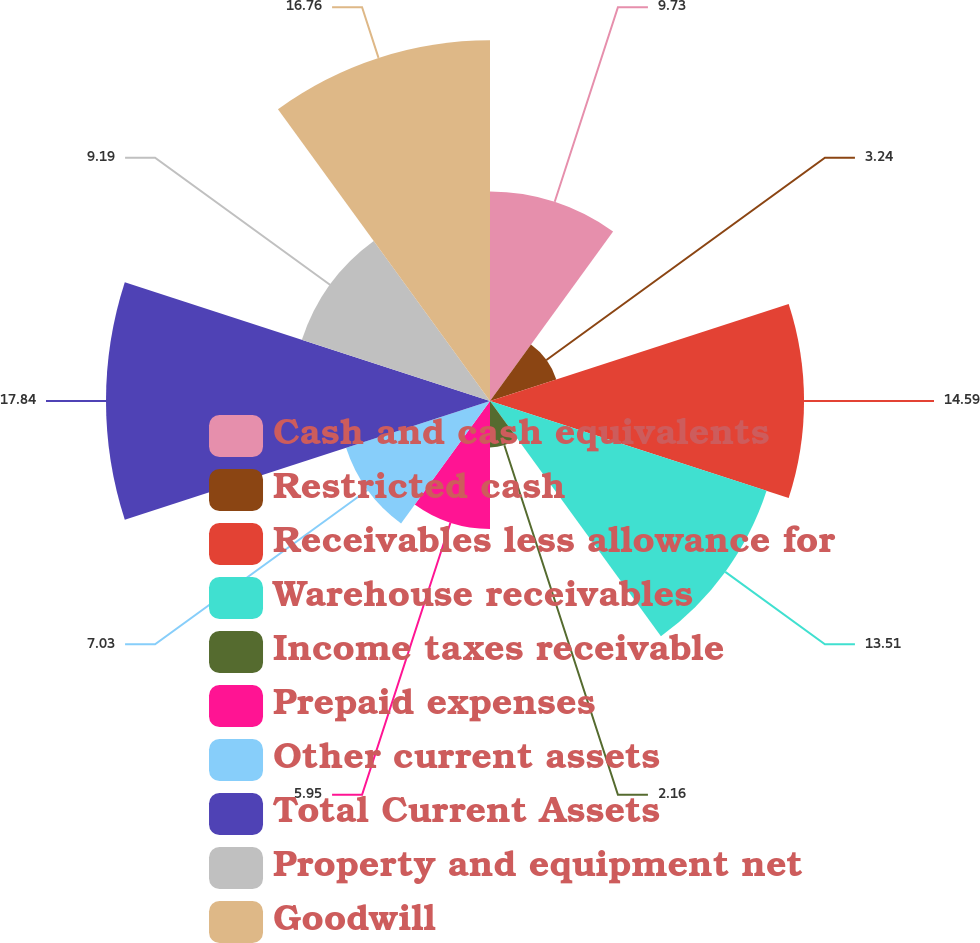Convert chart to OTSL. <chart><loc_0><loc_0><loc_500><loc_500><pie_chart><fcel>Cash and cash equivalents<fcel>Restricted cash<fcel>Receivables less allowance for<fcel>Warehouse receivables<fcel>Income taxes receivable<fcel>Prepaid expenses<fcel>Other current assets<fcel>Total Current Assets<fcel>Property and equipment net<fcel>Goodwill<nl><fcel>9.73%<fcel>3.24%<fcel>14.59%<fcel>13.51%<fcel>2.16%<fcel>5.95%<fcel>7.03%<fcel>17.84%<fcel>9.19%<fcel>16.76%<nl></chart> 